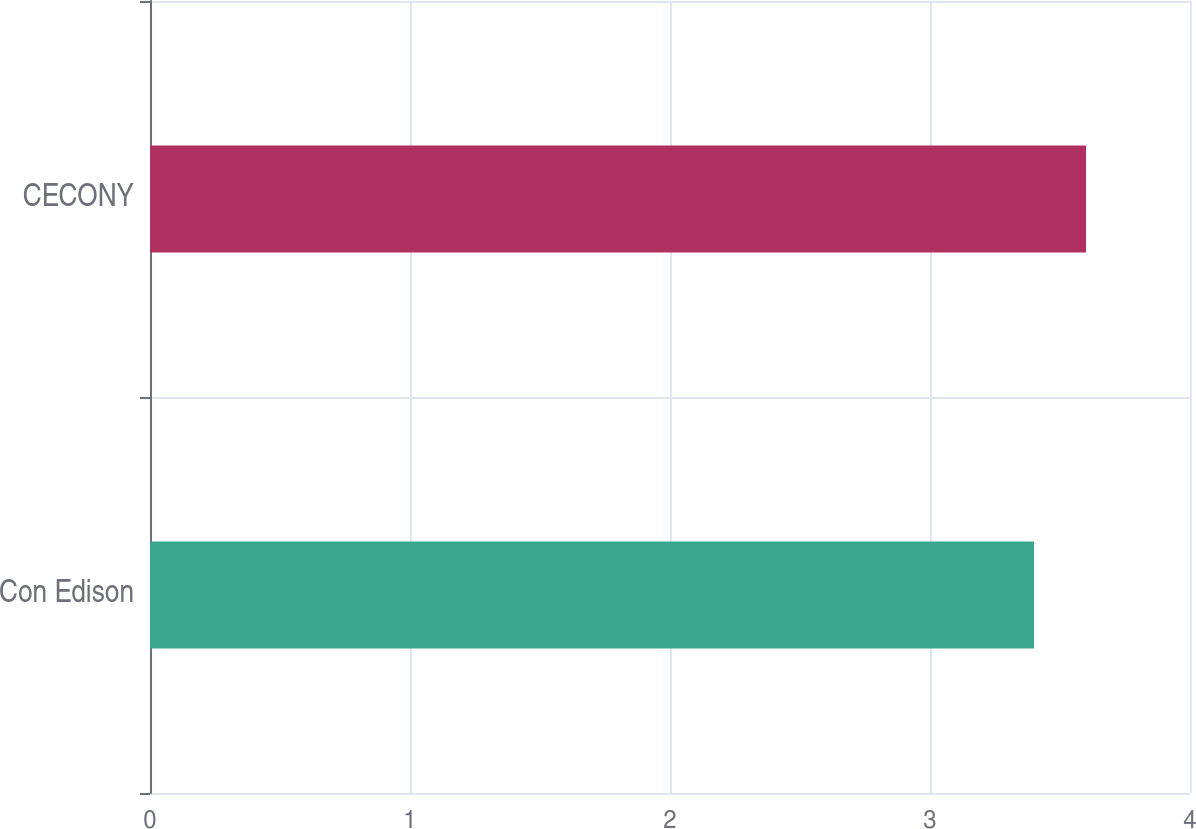Convert chart to OTSL. <chart><loc_0><loc_0><loc_500><loc_500><bar_chart><fcel>Con Edison<fcel>CECONY<nl><fcel>3.4<fcel>3.6<nl></chart> 